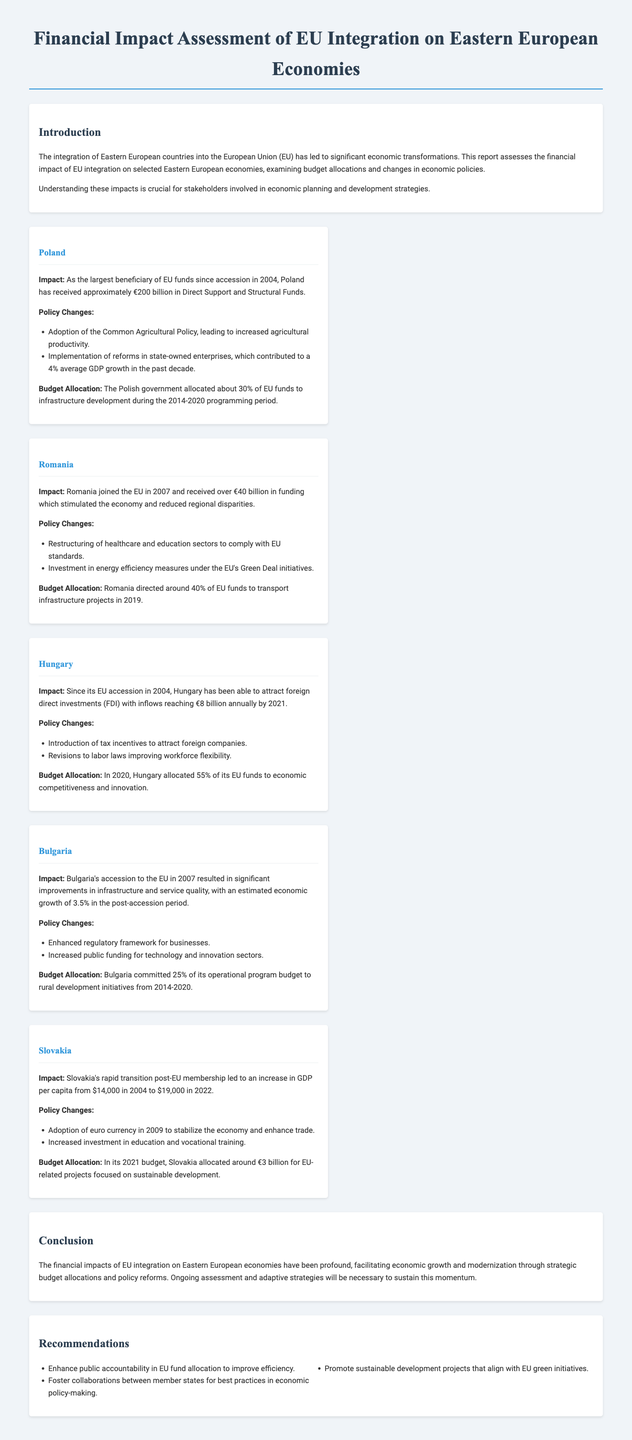What is the total EU funding Poland received? The document states that Poland has received approximately €200 billion in Direct Support and Structural Funds since accession in 2004.
Answer: €200 billion What percentage of EU funds did Romania allocate to transport infrastructure projects in 2019? The report indicates that Romania directed around 40% of EU funds to transport infrastructure projects in 2019.
Answer: 40% How much did Hungary attract in foreign direct investments annually by 2021? According to the document, Hungary was able to attract foreign direct investments with inflows reaching €8 billion annually by 2021.
Answer: €8 billion What was the average GDP growth in Poland in the past decade? The report mentions that Poland's state-owned enterprise reforms contributed to a 4% average GDP growth in the past decade.
Answer: 4% What was the GDP per capita in Slovakia in 2004? The document states that Slovakia's GDP per capita was $14,000 in 2004.
Answer: $14,000 What was Bulgaria's economic growth estimate in the post-accession period? The report notes that Bulgaria experienced an estimated economic growth of 3.5% in the post-accession period.
Answer: 3.5% What proportion of Hungary's EU funds was allocated to economic competitiveness in 2020? The document specifies that Hungary allocated 55% of its EU funds to economic competitiveness and innovation in 2020.
Answer: 55% What policy was adopted by Poland to increase agricultural productivity? The document highlights the adoption of the Common Agricultural Policy in Poland as a measure to increase agricultural productivity.
Answer: Common Agricultural Policy What year did Romania join the EU? The report indicates that Romania joined the EU in 2007.
Answer: 2007 What is a recommendation provided in the report regarding the allocation of EU funds? One of the recommendations suggests enhancing public accountability in EU fund allocation to improve efficiency.
Answer: Enhance public accountability 